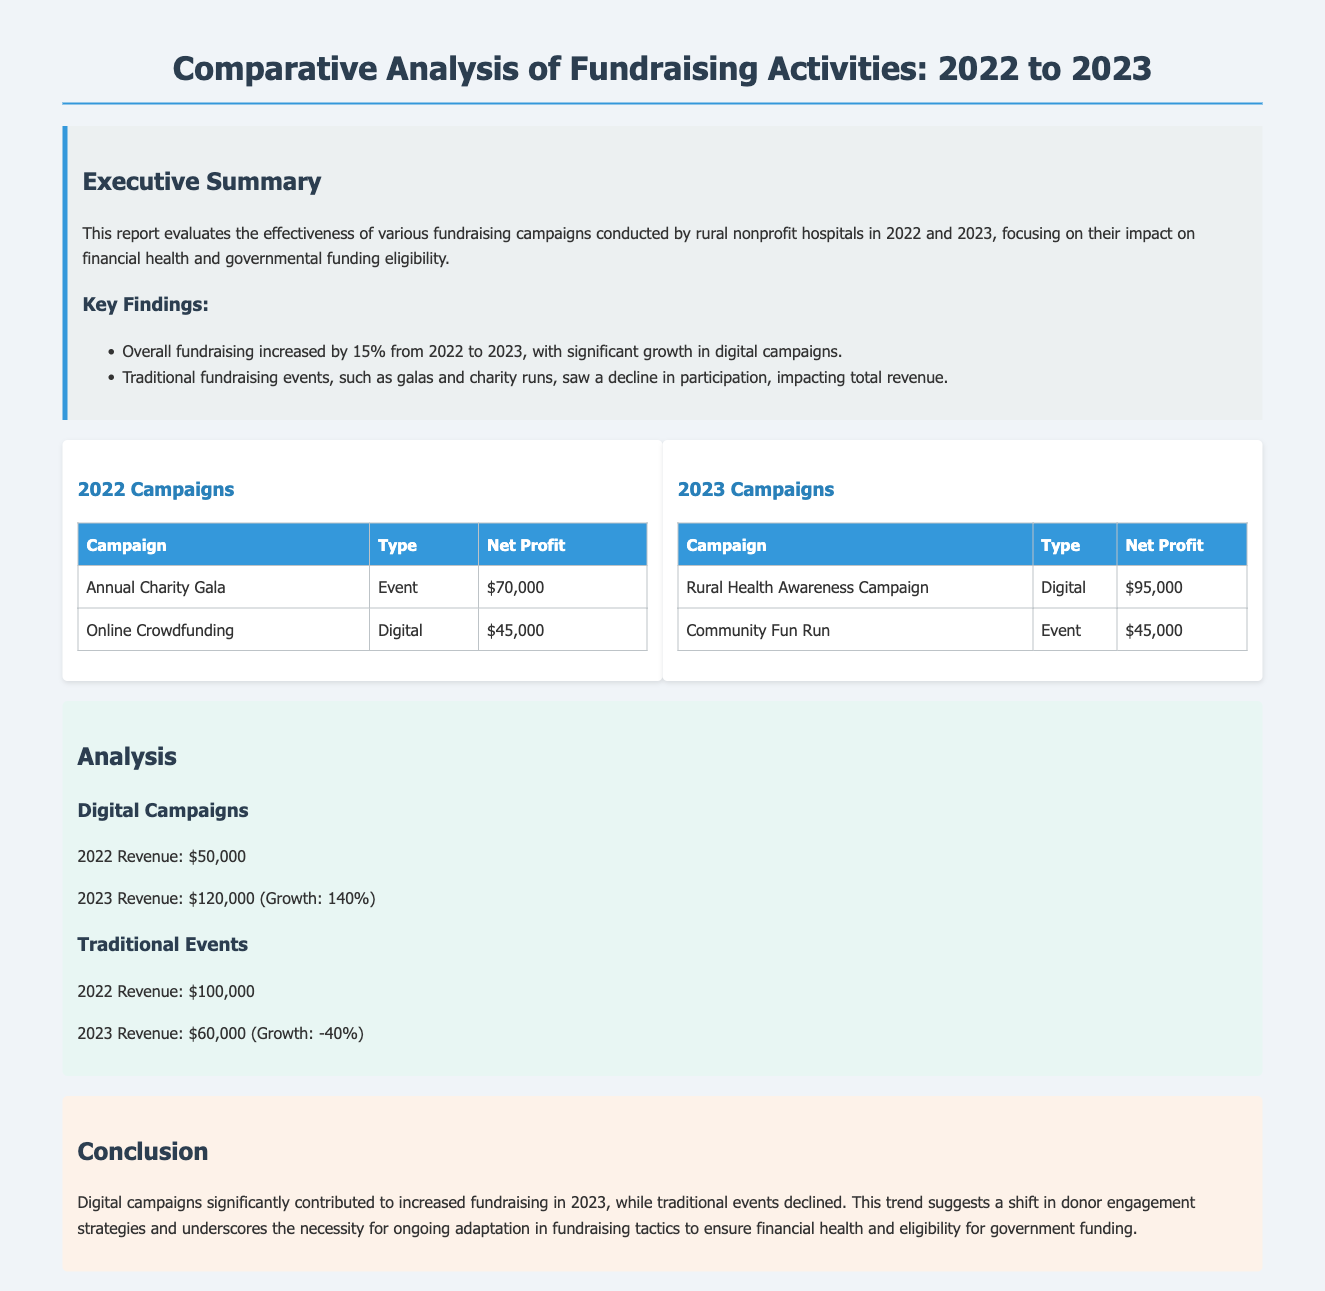What was the percentage increase in overall fundraising from 2022 to 2023? The report states that overall fundraising increased by 15% from 2022 to 2023.
Answer: 15% What was the net profit of the Annual Charity Gala in 2022? The table for 2022 campaigns shows the net profit for the Annual Charity Gala was $70,000.
Answer: $70,000 What type of campaign generated the highest revenue in 2023? The Rural Health Awareness Campaign is highlighted as generating the highest net profit in 2023 with $95,000.
Answer: Digital What was the net profit of the Community Fun Run in 2023? According to the table, the net profit for the Community Fun Run in 2023 was $45,000.
Answer: $45,000 By how much did digital campaign revenue grow from 2022 to 2023? The analysis indicates that digital revenue grew from $50,000 in 2022 to $120,000 in 2023, which is a growth of 140%.
Answer: 140% Which fundraising method experienced a decline in 2023? The document mentions that traditional fundraising events saw a decline in participation, impacting total revenue.
Answer: Traditional events What was the total revenue from traditional events in 2022? The analysis states that total revenue from traditional events in 2022 was $100,000.
Answer: $100,000 What color represents the background of the executive summary section? The executive summary section has a background color of #ecf0f1.
Answer: Light gray What key finding indicates a shift in fundraising strategies? The report highlights that digital campaigns significantly contributed to increased fundraising in 2023, suggesting a shift in donor engagement strategies.
Answer: Digital campaigns 